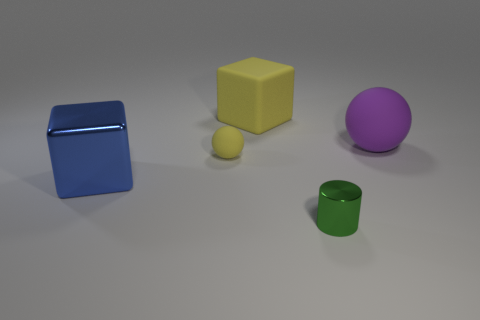What is the size of the matte ball that is in front of the purple rubber sphere to the right of the rubber object behind the purple object?
Ensure brevity in your answer.  Small. There is a big thing that is right of the large block that is on the right side of the large cube on the left side of the matte block; what shape is it?
Your answer should be very brief. Sphere. What shape is the yellow matte thing that is behind the small rubber sphere?
Provide a succinct answer. Cube. Are the cylinder and the ball that is on the right side of the small green thing made of the same material?
Offer a very short reply. No. How many other things are there of the same shape as the big blue object?
Ensure brevity in your answer.  1. Does the big sphere have the same color as the big thing in front of the small rubber thing?
Your answer should be very brief. No. Is there anything else that is made of the same material as the blue object?
Offer a terse response. Yes. What is the shape of the small object that is in front of the large object in front of the tiny yellow matte sphere?
Make the answer very short. Cylinder. There is a cube that is the same color as the small rubber object; what size is it?
Your answer should be compact. Large. Is the shape of the rubber object that is right of the green metal cylinder the same as  the big blue thing?
Ensure brevity in your answer.  No. 